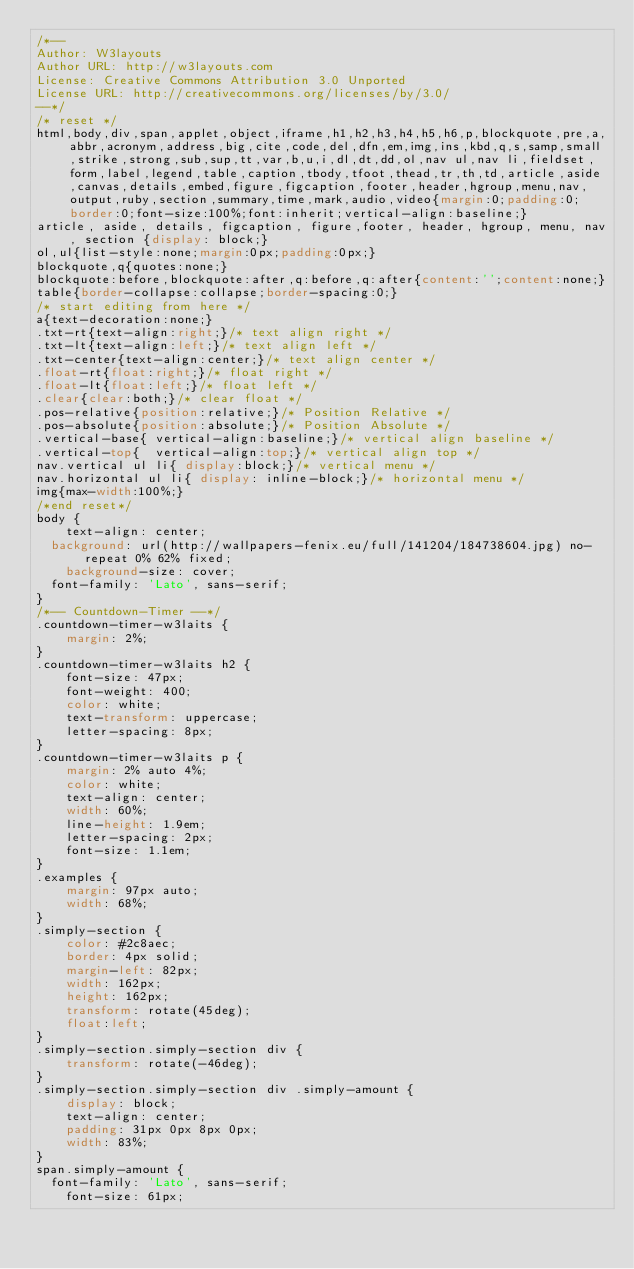<code> <loc_0><loc_0><loc_500><loc_500><_CSS_>/*--
Author: W3layouts
Author URL: http://w3layouts.com
License: Creative Commons Attribution 3.0 Unported
License URL: http://creativecommons.org/licenses/by/3.0/
--*/
/* reset */
html,body,div,span,applet,object,iframe,h1,h2,h3,h4,h5,h6,p,blockquote,pre,a,abbr,acronym,address,big,cite,code,del,dfn,em,img,ins,kbd,q,s,samp,small,strike,strong,sub,sup,tt,var,b,u,i,dl,dt,dd,ol,nav ul,nav li,fieldset,form,label,legend,table,caption,tbody,tfoot,thead,tr,th,td,article,aside,canvas,details,embed,figure,figcaption,footer,header,hgroup,menu,nav,output,ruby,section,summary,time,mark,audio,video{margin:0;padding:0;border:0;font-size:100%;font:inherit;vertical-align:baseline;}
article, aside, details, figcaption, figure,footer, header, hgroup, menu, nav, section {display: block;}
ol,ul{list-style:none;margin:0px;padding:0px;}
blockquote,q{quotes:none;}
blockquote:before,blockquote:after,q:before,q:after{content:'';content:none;}
table{border-collapse:collapse;border-spacing:0;}
/* start editing from here */
a{text-decoration:none;}
.txt-rt{text-align:right;}/* text align right */
.txt-lt{text-align:left;}/* text align left */
.txt-center{text-align:center;}/* text align center */
.float-rt{float:right;}/* float right */
.float-lt{float:left;}/* float left */
.clear{clear:both;}/* clear float */
.pos-relative{position:relative;}/* Position Relative */
.pos-absolute{position:absolute;}/* Position Absolute */
.vertical-base{	vertical-align:baseline;}/* vertical align baseline */
.vertical-top{	vertical-align:top;}/* vertical align top */
nav.vertical ul li{	display:block;}/* vertical menu */
nav.horizontal ul li{	display: inline-block;}/* horizontal menu */
img{max-width:100%;}
/*end reset*/
body {
    text-align: center;
	background: url(http://wallpapers-fenix.eu/full/141204/184738604.jpg) no-repeat 0% 62% fixed;
    background-size: cover;
	font-family: 'Lato', sans-serif;
}
/*-- Countdown-Timer --*/
.countdown-timer-w3laits {
    margin: 2%;
}
.countdown-timer-w3laits h2 {
    font-size: 47px;
    font-weight: 400;
    color: white;
    text-transform: uppercase;
    letter-spacing: 8px;
}
.countdown-timer-w3laits p {
    margin: 2% auto 4%;
    color: white;
    text-align: center;
    width: 60%;
    line-height: 1.9em;
    letter-spacing: 2px;
    font-size: 1.1em;
}
.examples {
    margin: 97px auto;
    width: 68%;
}
.simply-section {
    color: #2c8aec;
    border: 4px solid;
    margin-left: 82px;
    width: 162px;
    height: 162px;
    transform: rotate(45deg);
    float:left;
}
.simply-section.simply-section div {
    transform: rotate(-46deg);
}
.simply-section.simply-section div .simply-amount {
    display: block;
    text-align: center;
    padding: 31px 0px 8px 0px;
    width: 83%;
}
span.simply-amount {
	font-family: 'Lato', sans-serif;
    font-size: 61px;</code> 